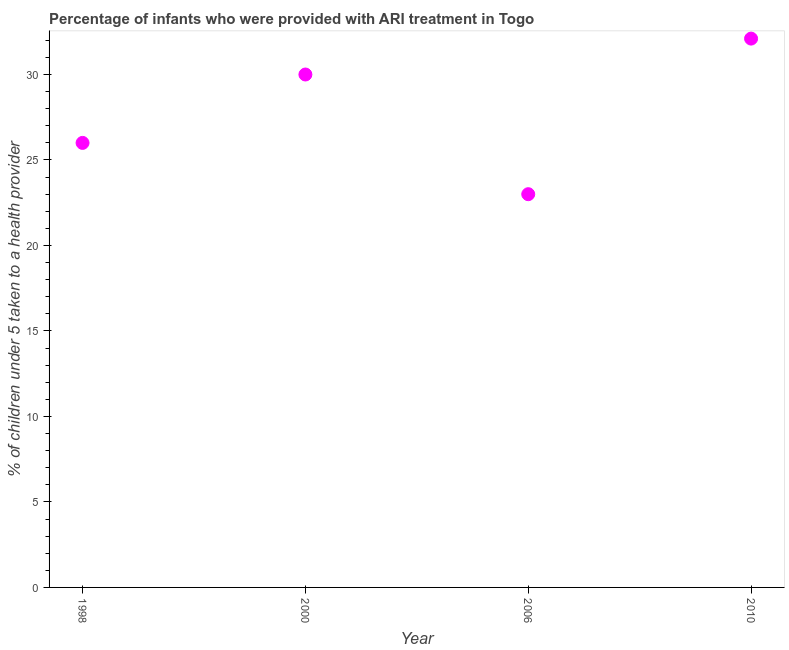Across all years, what is the maximum percentage of children who were provided with ari treatment?
Make the answer very short. 32.1. Across all years, what is the minimum percentage of children who were provided with ari treatment?
Offer a very short reply. 23. In which year was the percentage of children who were provided with ari treatment minimum?
Give a very brief answer. 2006. What is the sum of the percentage of children who were provided with ari treatment?
Your response must be concise. 111.1. What is the difference between the percentage of children who were provided with ari treatment in 1998 and 2006?
Make the answer very short. 3. What is the average percentage of children who were provided with ari treatment per year?
Provide a short and direct response. 27.77. In how many years, is the percentage of children who were provided with ari treatment greater than 31 %?
Make the answer very short. 1. Do a majority of the years between 2000 and 2006 (inclusive) have percentage of children who were provided with ari treatment greater than 26 %?
Give a very brief answer. No. What is the ratio of the percentage of children who were provided with ari treatment in 1998 to that in 2006?
Your answer should be very brief. 1.13. Is the percentage of children who were provided with ari treatment in 2000 less than that in 2006?
Give a very brief answer. No. What is the difference between the highest and the second highest percentage of children who were provided with ari treatment?
Make the answer very short. 2.1. Is the sum of the percentage of children who were provided with ari treatment in 1998 and 2006 greater than the maximum percentage of children who were provided with ari treatment across all years?
Provide a short and direct response. Yes. What is the difference between the highest and the lowest percentage of children who were provided with ari treatment?
Give a very brief answer. 9.1. How many years are there in the graph?
Provide a short and direct response. 4. What is the title of the graph?
Your response must be concise. Percentage of infants who were provided with ARI treatment in Togo. What is the label or title of the X-axis?
Your answer should be very brief. Year. What is the label or title of the Y-axis?
Make the answer very short. % of children under 5 taken to a health provider. What is the % of children under 5 taken to a health provider in 1998?
Your answer should be very brief. 26. What is the % of children under 5 taken to a health provider in 2010?
Provide a short and direct response. 32.1. What is the difference between the % of children under 5 taken to a health provider in 1998 and 2006?
Offer a terse response. 3. What is the difference between the % of children under 5 taken to a health provider in 1998 and 2010?
Give a very brief answer. -6.1. What is the ratio of the % of children under 5 taken to a health provider in 1998 to that in 2000?
Keep it short and to the point. 0.87. What is the ratio of the % of children under 5 taken to a health provider in 1998 to that in 2006?
Ensure brevity in your answer.  1.13. What is the ratio of the % of children under 5 taken to a health provider in 1998 to that in 2010?
Provide a short and direct response. 0.81. What is the ratio of the % of children under 5 taken to a health provider in 2000 to that in 2006?
Ensure brevity in your answer.  1.3. What is the ratio of the % of children under 5 taken to a health provider in 2000 to that in 2010?
Your response must be concise. 0.94. What is the ratio of the % of children under 5 taken to a health provider in 2006 to that in 2010?
Make the answer very short. 0.72. 